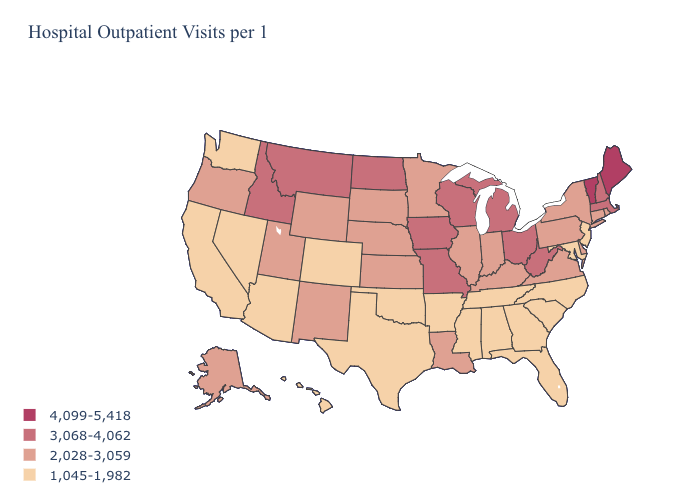How many symbols are there in the legend?
Short answer required. 4. Which states have the lowest value in the South?
Keep it brief. Alabama, Arkansas, Florida, Georgia, Maryland, Mississippi, North Carolina, Oklahoma, South Carolina, Tennessee, Texas. Name the states that have a value in the range 3,068-4,062?
Be succinct. Idaho, Iowa, Massachusetts, Michigan, Missouri, Montana, New Hampshire, North Dakota, Ohio, West Virginia, Wisconsin. Which states have the lowest value in the MidWest?
Answer briefly. Illinois, Indiana, Kansas, Minnesota, Nebraska, South Dakota. What is the value of South Dakota?
Answer briefly. 2,028-3,059. Among the states that border Texas , which have the highest value?
Quick response, please. Louisiana, New Mexico. What is the value of Ohio?
Short answer required. 3,068-4,062. What is the lowest value in the West?
Give a very brief answer. 1,045-1,982. Is the legend a continuous bar?
Answer briefly. No. What is the value of Illinois?
Write a very short answer. 2,028-3,059. Does New Hampshire have a lower value than Vermont?
Be succinct. Yes. Name the states that have a value in the range 3,068-4,062?
Answer briefly. Idaho, Iowa, Massachusetts, Michigan, Missouri, Montana, New Hampshire, North Dakota, Ohio, West Virginia, Wisconsin. Does West Virginia have a lower value than Vermont?
Be succinct. Yes. Does the first symbol in the legend represent the smallest category?
Short answer required. No. Among the states that border Massachusetts , which have the lowest value?
Be succinct. Connecticut, New York, Rhode Island. 